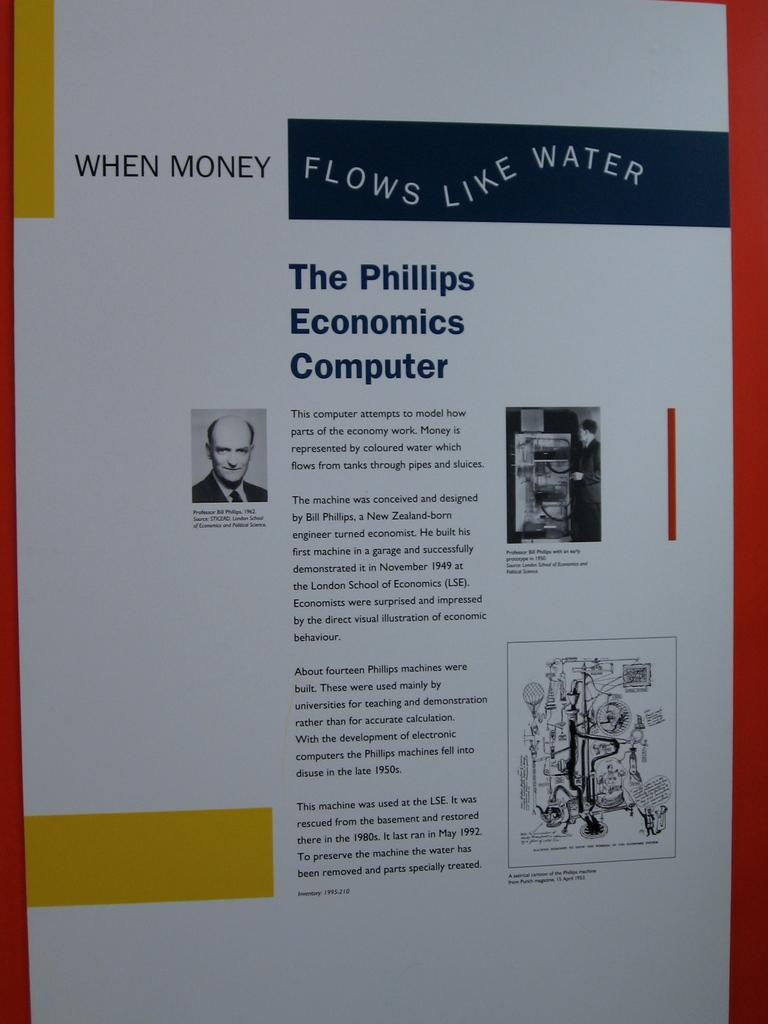Provide a one-sentence caption for the provided image. An article of one of the first computers called The Phillips Economics Computer. 